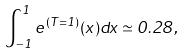<formula> <loc_0><loc_0><loc_500><loc_500>\int _ { - 1 } ^ { 1 } e ^ { ( T = 1 ) } ( x ) d x \simeq 0 . 2 8 ,</formula> 